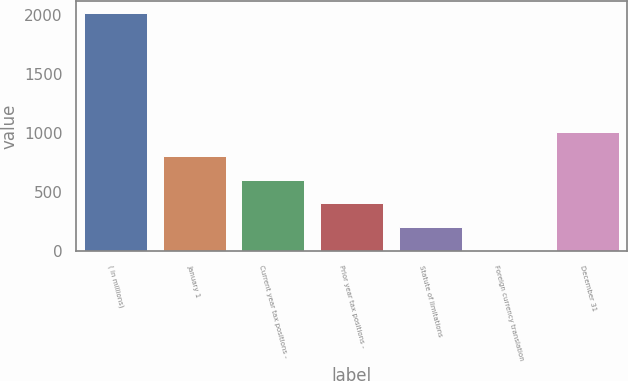<chart> <loc_0><loc_0><loc_500><loc_500><bar_chart><fcel>( in millions)<fcel>January 1<fcel>Current year tax positions -<fcel>Prior year tax positions -<fcel>Statute of limitations<fcel>Foreign currency translation<fcel>December 31<nl><fcel>2016<fcel>807.6<fcel>606.2<fcel>404.8<fcel>203.4<fcel>2<fcel>1009<nl></chart> 